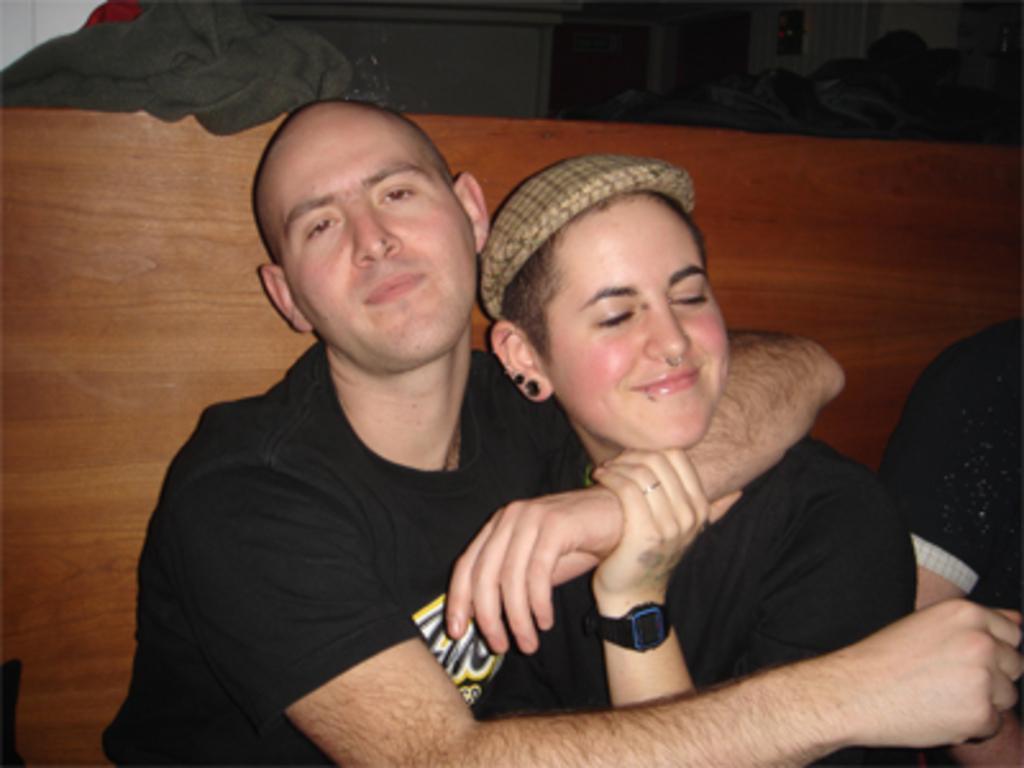In one or two sentences, can you explain what this image depicts? In this image, we can see people and one of them is wearing a cap. In the background, there is a board and we can see a cloth and there are some other objects. 